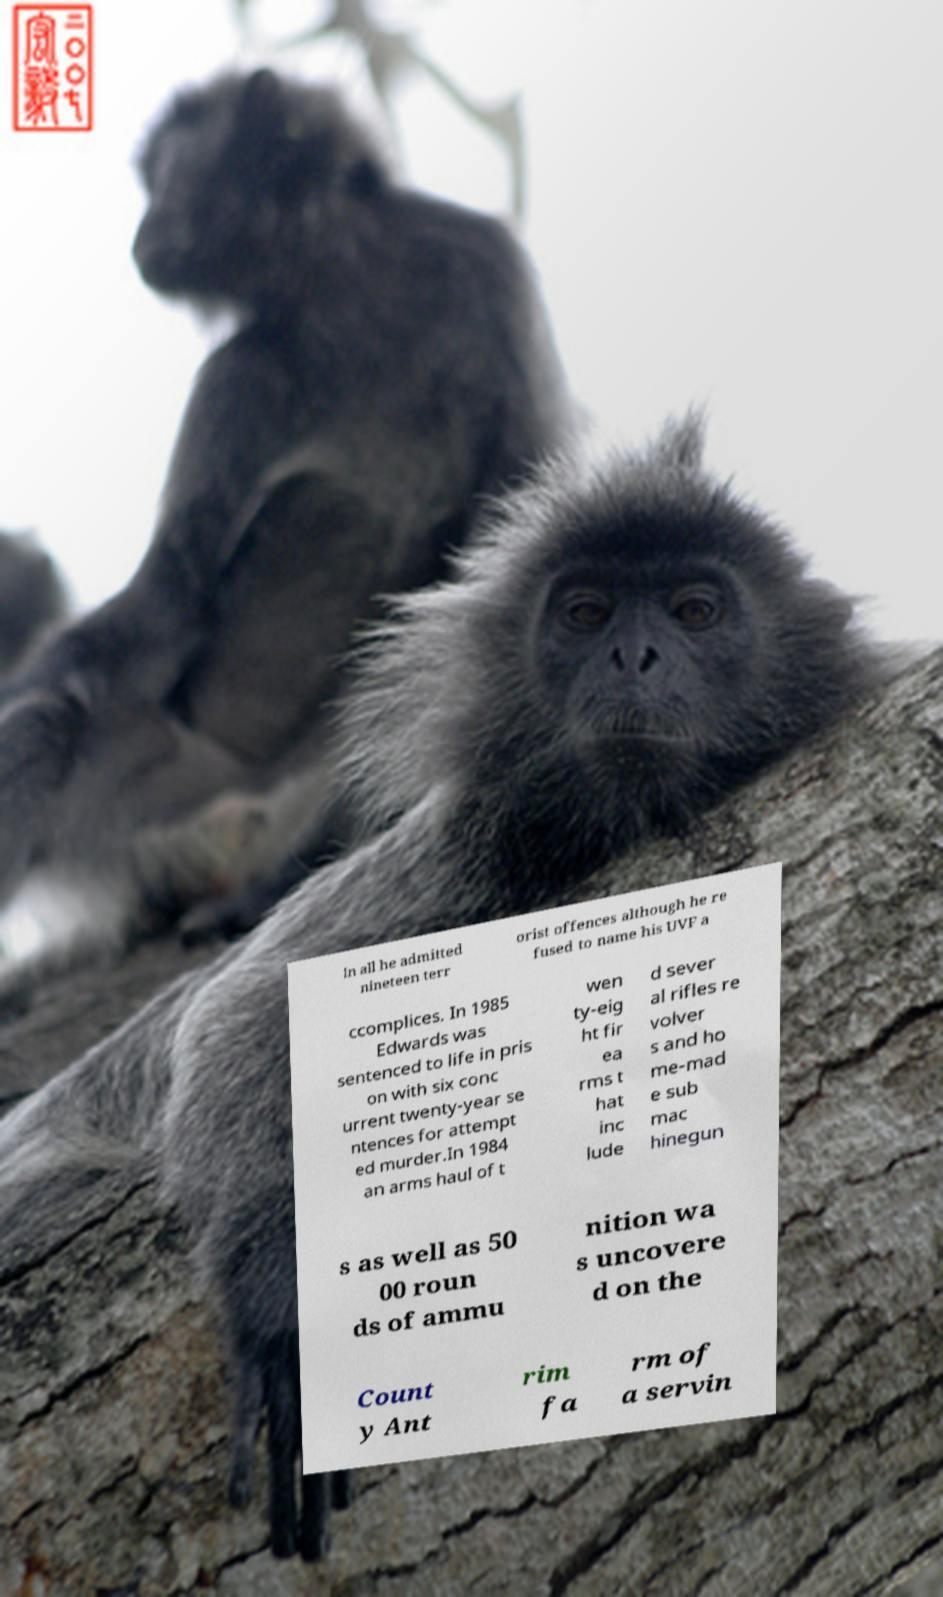Could you extract and type out the text from this image? In all he admitted nineteen terr orist offences although he re fused to name his UVF a ccomplices. In 1985 Edwards was sentenced to life in pris on with six conc urrent twenty-year se ntences for attempt ed murder.In 1984 an arms haul of t wen ty-eig ht fir ea rms t hat inc lude d sever al rifles re volver s and ho me-mad e sub mac hinegun s as well as 50 00 roun ds of ammu nition wa s uncovere d on the Count y Ant rim fa rm of a servin 